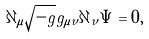Convert formula to latex. <formula><loc_0><loc_0><loc_500><loc_500>\partial _ { \mu } { \sqrt { - g } } g _ { { \mu } { \nu } } \partial _ { \nu } { \Psi } = 0 ,</formula> 